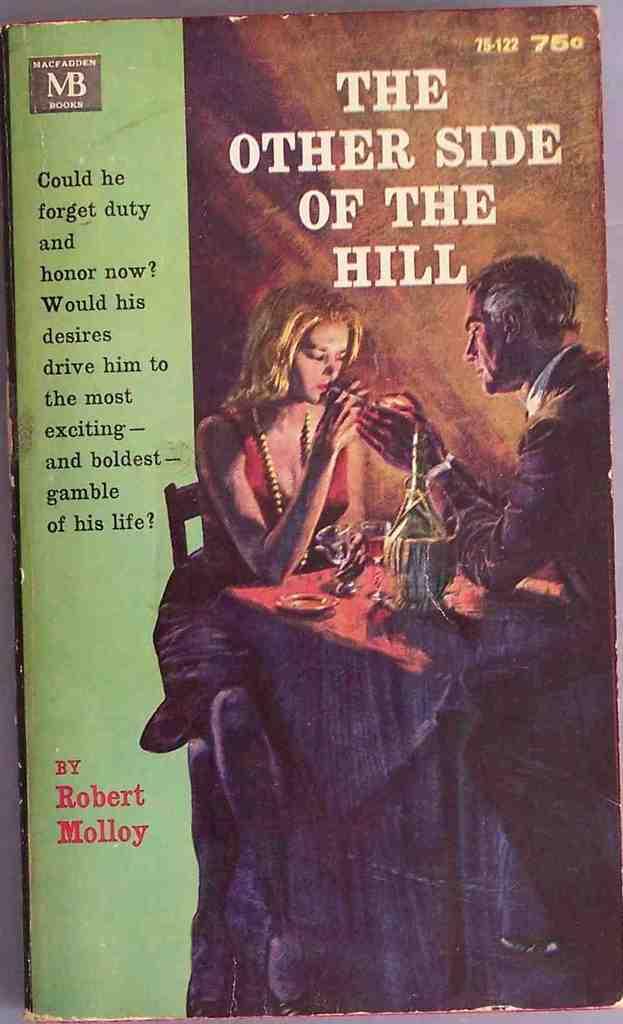Do you think this book is really old?
Provide a short and direct response. Answering does not require reading text in the image. Who wrote this story?
Offer a terse response. Robert molloy. 